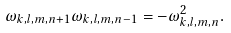Convert formula to latex. <formula><loc_0><loc_0><loc_500><loc_500>\omega _ { k , l , m , n + 1 } \omega _ { k , l , m , n - 1 } = - \omega _ { k , l , m , n } ^ { 2 } .</formula> 